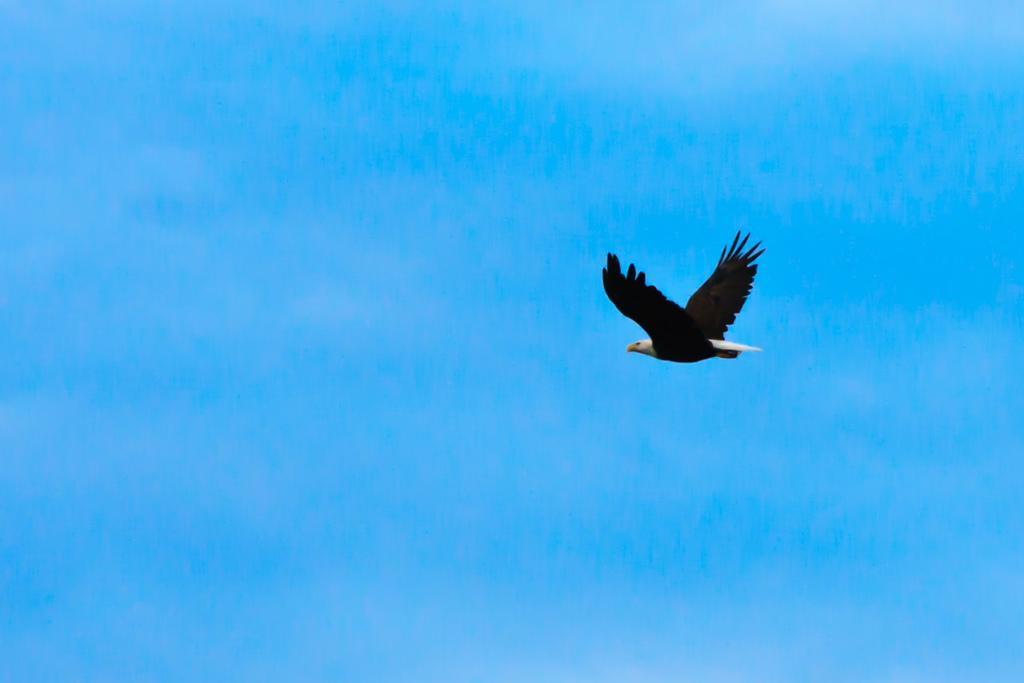Please provide a concise description of this image. In this picture there is a bird flying in the sky. At the top there is sky. 